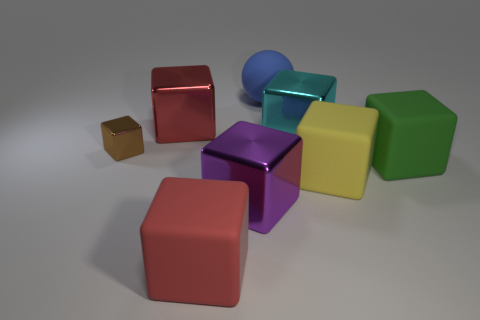How many blue spheres have the same material as the large yellow object?
Provide a succinct answer. 1. Does the matte ball that is behind the green object have the same size as the red block that is in front of the large green rubber block?
Make the answer very short. Yes. What is the color of the large metal object in front of the small brown thing?
Provide a succinct answer. Purple. How many other matte spheres are the same color as the rubber sphere?
Your response must be concise. 0. Do the purple object and the red object that is behind the big red matte thing have the same size?
Ensure brevity in your answer.  Yes. What is the size of the red cube in front of the red block that is behind the big metallic block in front of the large yellow matte thing?
Offer a very short reply. Large. How many red matte objects are to the right of the yellow object?
Your response must be concise. 0. What is the material of the red cube that is behind the big matte cube left of the large blue thing?
Your answer should be very brief. Metal. Are there any other things that are the same size as the blue ball?
Your response must be concise. Yes. Do the cyan metal block and the brown shiny cube have the same size?
Make the answer very short. No. 